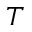<formula> <loc_0><loc_0><loc_500><loc_500>T</formula> 